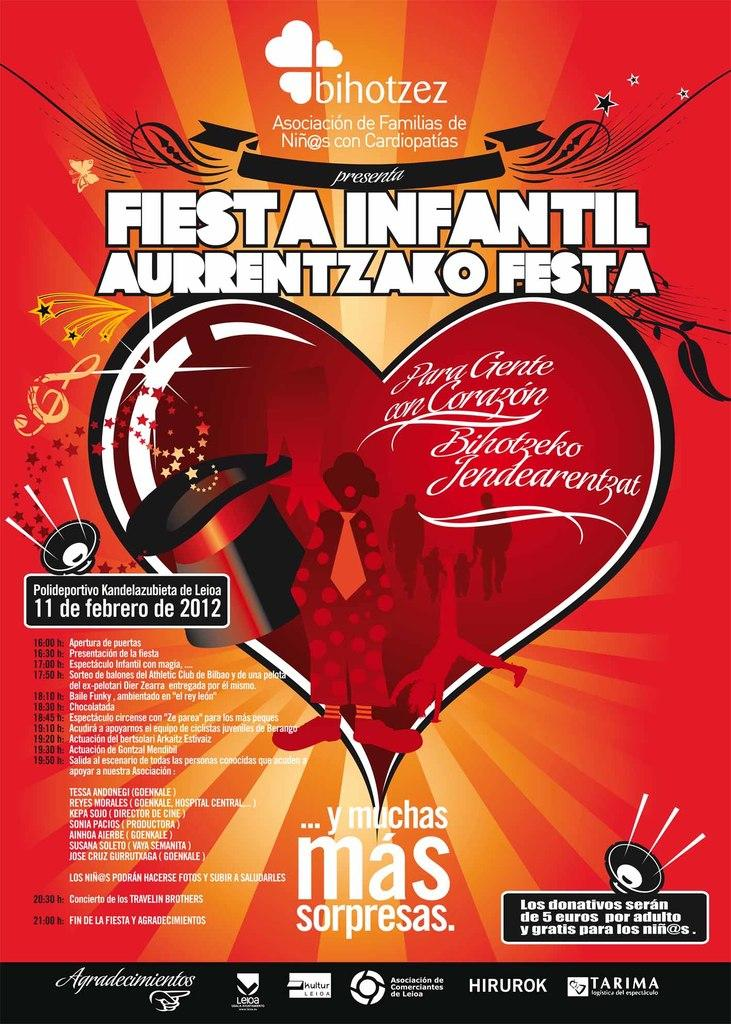<image>
Summarize the visual content of the image. A poster with the title Fiesta Infantil on it. 